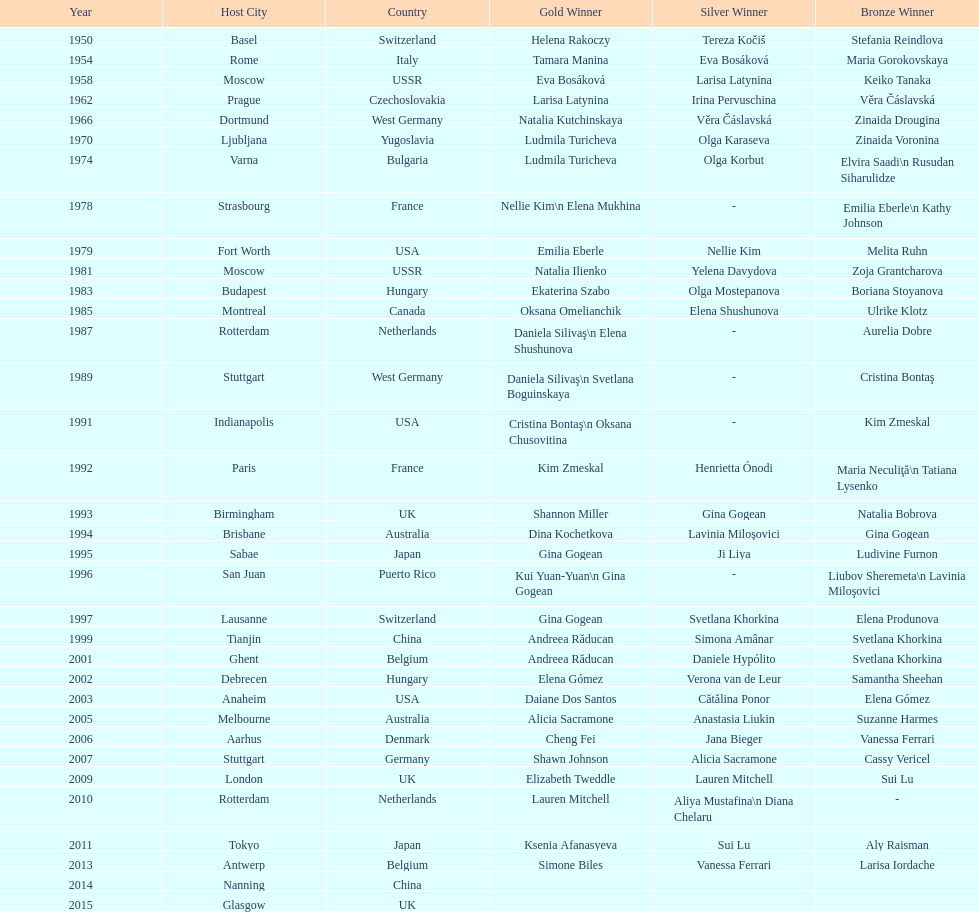Could you parse the entire table? {'header': ['Year', 'Host City', 'Country', 'Gold Winner', 'Silver Winner', 'Bronze Winner'], 'rows': [['1950', 'Basel', 'Switzerland', 'Helena Rakoczy', 'Tereza Kočiš', 'Stefania Reindlova'], ['1954', 'Rome', 'Italy', 'Tamara Manina', 'Eva Bosáková', 'Maria Gorokovskaya'], ['1958', 'Moscow', 'USSR', 'Eva Bosáková', 'Larisa Latynina', 'Keiko Tanaka'], ['1962', 'Prague', 'Czechoslovakia', 'Larisa Latynina', 'Irina Pervuschina', 'Věra Čáslavská'], ['1966', 'Dortmund', 'West Germany', 'Natalia Kutchinskaya', 'Věra Čáslavská', 'Zinaida Drougina'], ['1970', 'Ljubljana', 'Yugoslavia', 'Ludmila Turicheva', 'Olga Karaseva', 'Zinaida Voronina'], ['1974', 'Varna', 'Bulgaria', 'Ludmila Turicheva', 'Olga Korbut', 'Elvira Saadi\\n Rusudan Siharulidze'], ['1978', 'Strasbourg', 'France', 'Nellie Kim\\n Elena Mukhina', '-', 'Emilia Eberle\\n Kathy Johnson'], ['1979', 'Fort Worth', 'USA', 'Emilia Eberle', 'Nellie Kim', 'Melita Ruhn'], ['1981', 'Moscow', 'USSR', 'Natalia Ilienko', 'Yelena Davydova', 'Zoja Grantcharova'], ['1983', 'Budapest', 'Hungary', 'Ekaterina Szabo', 'Olga Mostepanova', 'Boriana Stoyanova'], ['1985', 'Montreal', 'Canada', 'Oksana Omelianchik', 'Elena Shushunova', 'Ulrike Klotz'], ['1987', 'Rotterdam', 'Netherlands', 'Daniela Silivaş\\n Elena Shushunova', '-', 'Aurelia Dobre'], ['1989', 'Stuttgart', 'West Germany', 'Daniela Silivaş\\n Svetlana Boguinskaya', '-', 'Cristina Bontaş'], ['1991', 'Indianapolis', 'USA', 'Cristina Bontaş\\n Oksana Chusovitina', '-', 'Kim Zmeskal'], ['1992', 'Paris', 'France', 'Kim Zmeskal', 'Henrietta Ónodi', 'Maria Neculiţă\\n Tatiana Lysenko'], ['1993', 'Birmingham', 'UK', 'Shannon Miller', 'Gina Gogean', 'Natalia Bobrova'], ['1994', 'Brisbane', 'Australia', 'Dina Kochetkova', 'Lavinia Miloşovici', 'Gina Gogean'], ['1995', 'Sabae', 'Japan', 'Gina Gogean', 'Ji Liya', 'Ludivine Furnon'], ['1996', 'San Juan', 'Puerto Rico', 'Kui Yuan-Yuan\\n Gina Gogean', '-', 'Liubov Sheremeta\\n Lavinia Miloşovici'], ['1997', 'Lausanne', 'Switzerland', 'Gina Gogean', 'Svetlana Khorkina', 'Elena Produnova'], ['1999', 'Tianjin', 'China', 'Andreea Răducan', 'Simona Amânar', 'Svetlana Khorkina'], ['2001', 'Ghent', 'Belgium', 'Andreea Răducan', 'Daniele Hypólito', 'Svetlana Khorkina'], ['2002', 'Debrecen', 'Hungary', 'Elena Gómez', 'Verona van de Leur', 'Samantha Sheehan'], ['2003', 'Anaheim', 'USA', 'Daiane Dos Santos', 'Cătălina Ponor', 'Elena Gómez'], ['2005', 'Melbourne', 'Australia', 'Alicia Sacramone', 'Anastasia Liukin', 'Suzanne Harmes'], ['2006', 'Aarhus', 'Denmark', 'Cheng Fei', 'Jana Bieger', 'Vanessa Ferrari'], ['2007', 'Stuttgart', 'Germany', 'Shawn Johnson', 'Alicia Sacramone', 'Cassy Vericel'], ['2009', 'London', 'UK', 'Elizabeth Tweddle', 'Lauren Mitchell', 'Sui Lu'], ['2010', 'Rotterdam', 'Netherlands', 'Lauren Mitchell', 'Aliya Mustafina\\n Diana Chelaru', '-'], ['2011', 'Tokyo', 'Japan', 'Ksenia Afanasyeva', 'Sui Lu', 'Aly Raisman'], ['2013', 'Antwerp', 'Belgium', 'Simone Biles', 'Vanessa Ferrari', 'Larisa Iordache'], ['2014', 'Nanning', 'China', '', '', ''], ['2015', 'Glasgow', 'UK', '', '', '']]} How many consecutive floor exercise gold medals did romanian star andreea raducan win at the world championships? 2. 